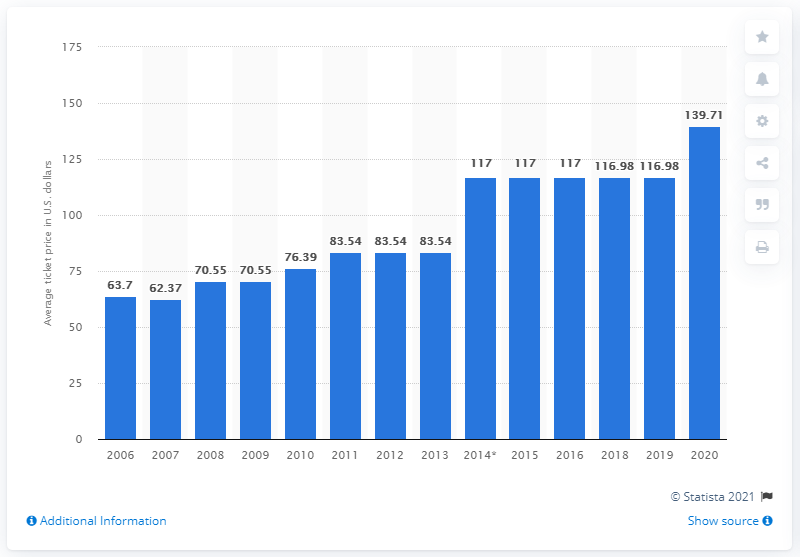List a handful of essential elements in this visual. In 2020, the average ticket price for San Francisco 49ers games was $139.71 per ticket. 